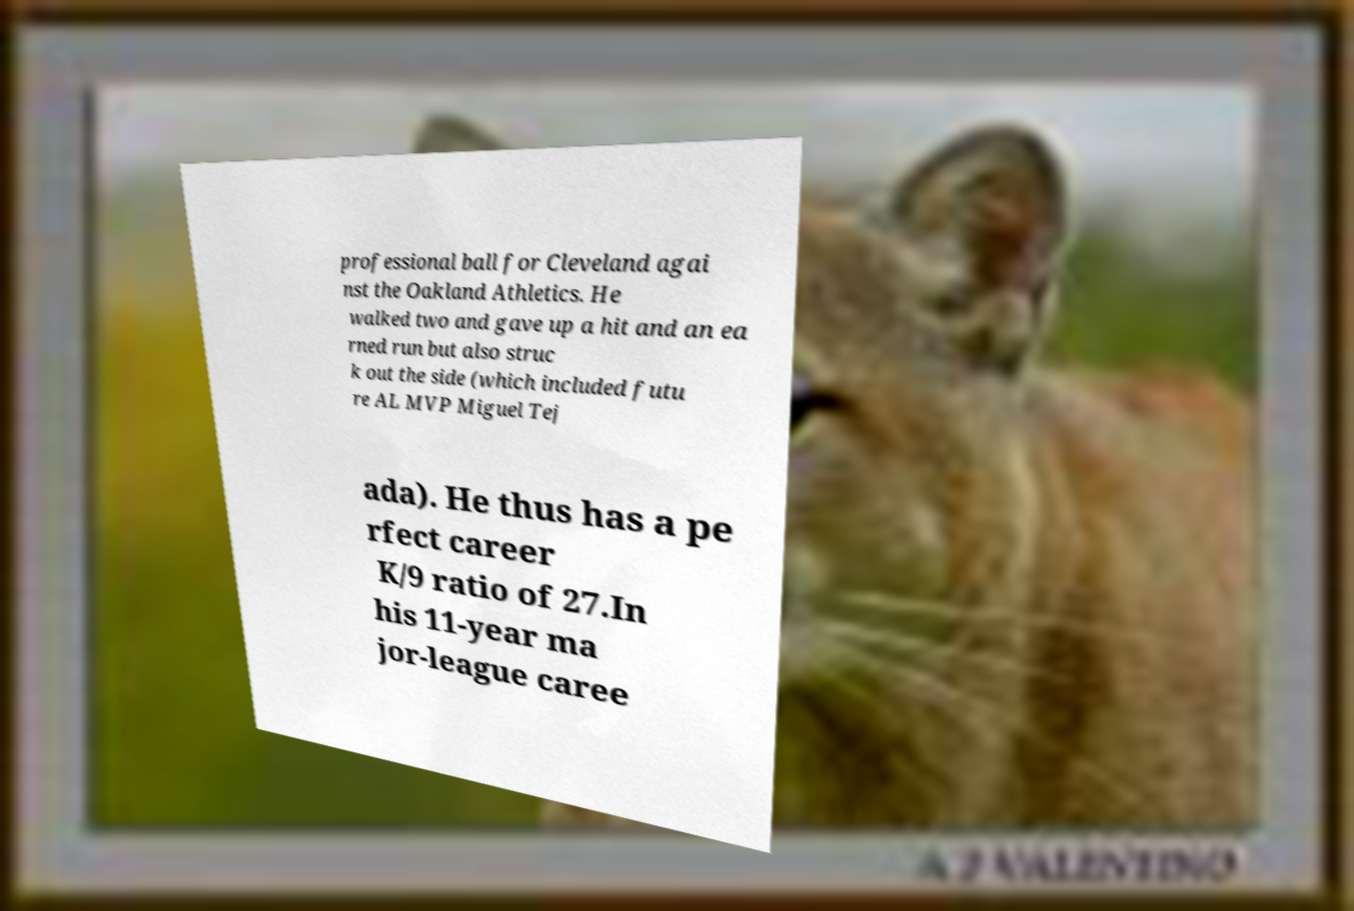Can you read and provide the text displayed in the image?This photo seems to have some interesting text. Can you extract and type it out for me? professional ball for Cleveland agai nst the Oakland Athletics. He walked two and gave up a hit and an ea rned run but also struc k out the side (which included futu re AL MVP Miguel Tej ada). He thus has a pe rfect career K/9 ratio of 27.In his 11-year ma jor-league caree 